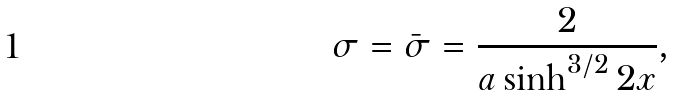Convert formula to latex. <formula><loc_0><loc_0><loc_500><loc_500>\sigma = \bar { \sigma } = \frac { 2 } { a \sinh ^ { 3 / 2 } 2 x } ,</formula> 